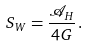Convert formula to latex. <formula><loc_0><loc_0><loc_500><loc_500>S _ { W } = \frac { \mathcal { A } _ { H } } { 4 G } \, .</formula> 